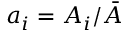<formula> <loc_0><loc_0><loc_500><loc_500>a _ { i } = A _ { i } / \bar { A }</formula> 